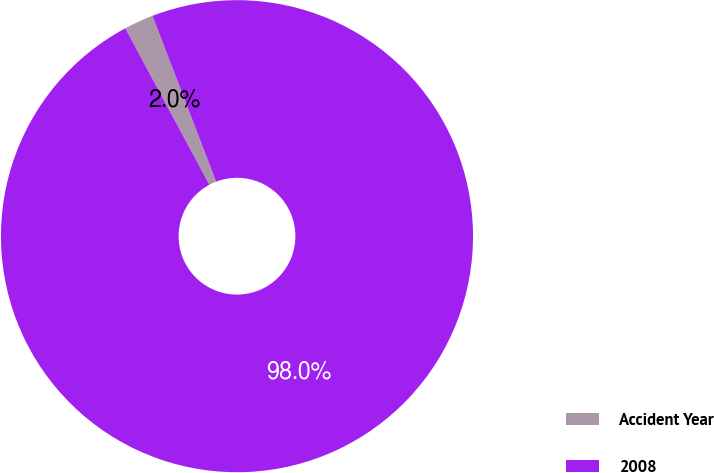<chart> <loc_0><loc_0><loc_500><loc_500><pie_chart><fcel>Accident Year<fcel>2008<nl><fcel>2.02%<fcel>97.98%<nl></chart> 